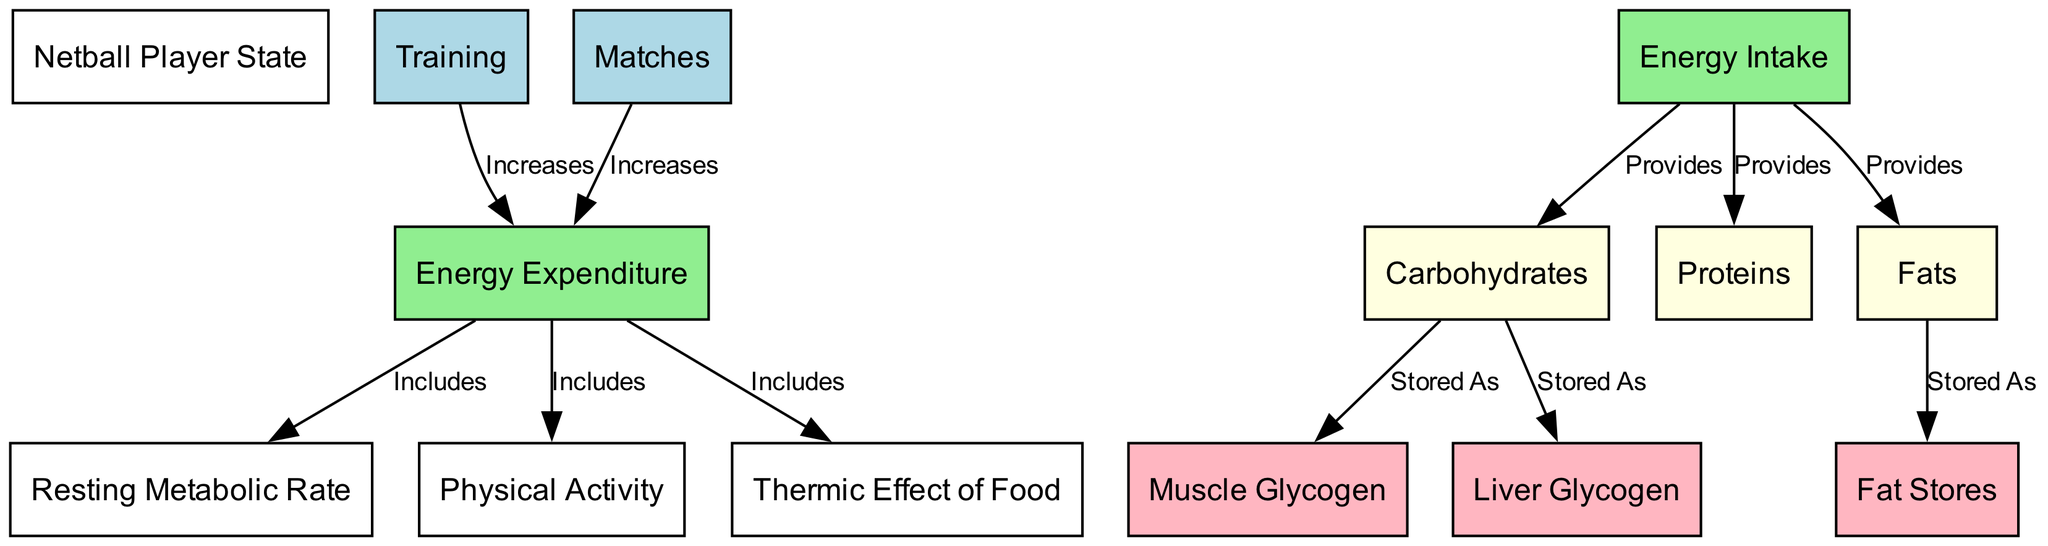What is the netball player state? The diagram labels the current state of the netball player as referred to, and it does not specify any other states in this context, thus remaining generic.
Answer: Netball Player State How many types of energy intake are represented? The diagram specifies three types of energy intake: carbohydrates, proteins, and fats. Thus, by simply counting the unique categories shown, we find a total of three.
Answer: Three What nodes increase energy expenditure? The nodes labeled 'Training' and 'Matches' specifically indicate actions that increase energy expenditure based on the directed edges connecting to the 'Energy Expenditure' node.
Answer: Training, Matches What does energy expenditure include? Energy expenditure encompasses the resting metabolic rate, physical activity, and the thermic effect of food as highlighted by the connecting edges leading from energy expenditure to these components.
Answer: Resting metabolic rate, physical activity, thermic effect of food Which storage types are associated with carbohydrates? According to the diagram, carbohydrates are stored as muscle glycogen and liver glycogen, both of which are directly connected to the carbohydrates node with directed edges labeled 'Stored As'.
Answer: Muscle glycogen, liver glycogen How does energy intake relate to energy expenditure? The energy intake influences the energy expenditure, as a higher energy intake can lead to increased energy expenditure particularly during training and matches; however, the specific relationship is illustrated through how they accumulate and are processed in the diagram.
Answer: Increases energy expenditure What is the relationship between fats and energy intake? The relationship is defined by the edge that connects 'Energy Intake' to 'Fats', which indicates that energy intake provides fats needed for the player's nutrition, critical for energy reserves.
Answer: Provides Which type of energy is categorized as 'Stored As' from fats? The fat-related energy is shown in the diagram to be stored as fat stores, linking the fats node directly to the fat stores node in a directed manner labeled 'Stored As'.
Answer: Fat stores 